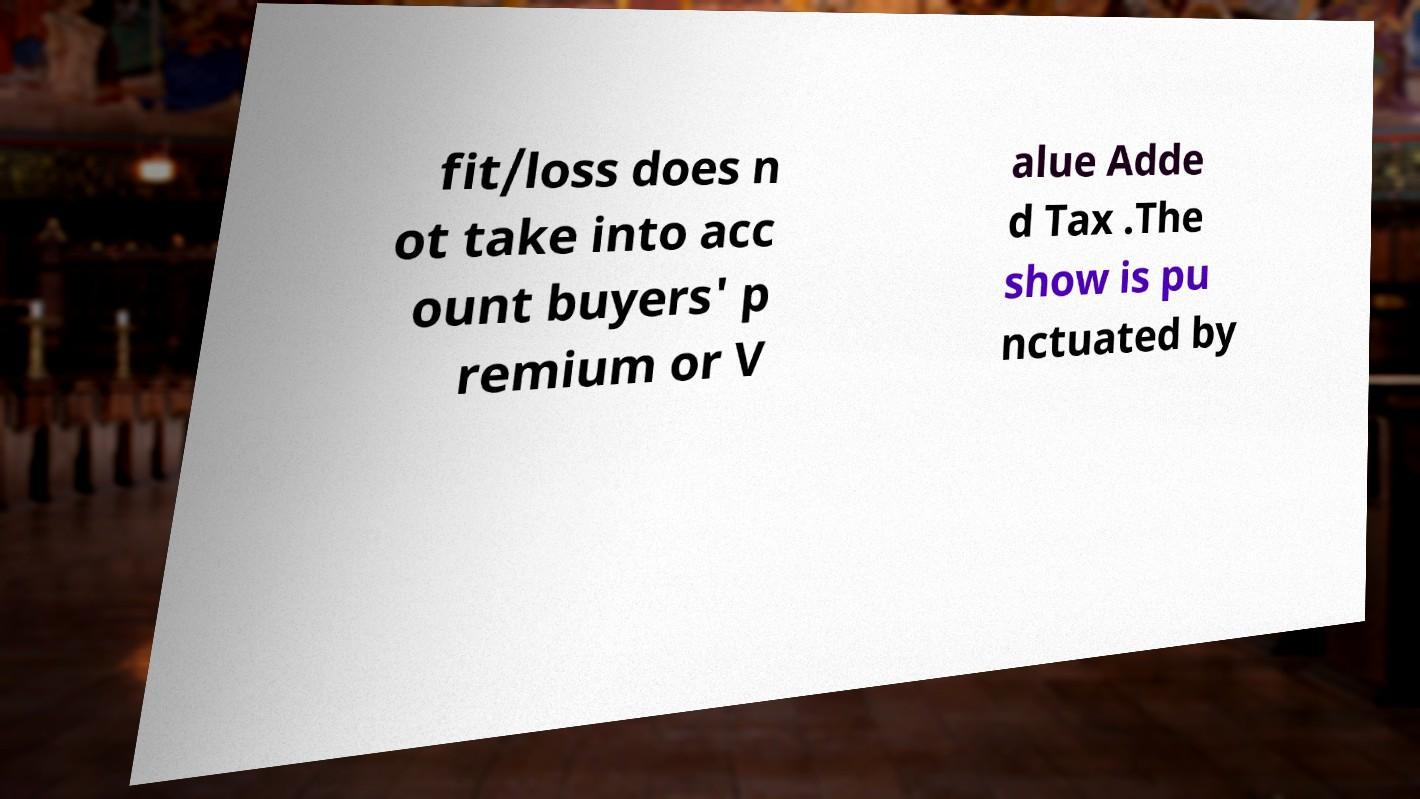I need the written content from this picture converted into text. Can you do that? fit/loss does n ot take into acc ount buyers' p remium or V alue Adde d Tax .The show is pu nctuated by 